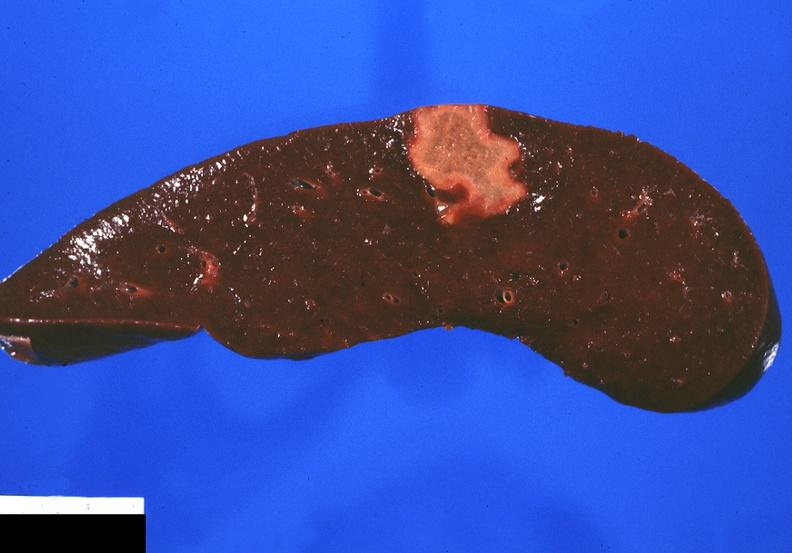s postpartum uterus present?
Answer the question using a single word or phrase. No 